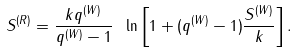<formula> <loc_0><loc_0><loc_500><loc_500>S ^ { ( R ) } = \frac { k q ^ { ( W ) } } { q ^ { ( W ) } - 1 } \ \ln \left [ 1 + ( q ^ { ( W ) } - 1 ) \frac { S ^ { ( W ) } } { k } \right ] .</formula> 